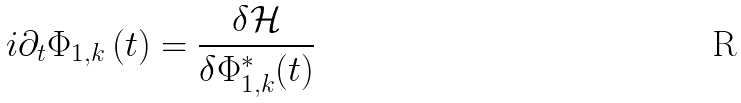<formula> <loc_0><loc_0><loc_500><loc_500>i \partial _ { t } { \Phi } _ { 1 , k } \left ( t \right ) = \frac { \delta \mathcal { H } } { \delta \Phi _ { 1 , k } ^ { \ast } ( t ) }</formula> 